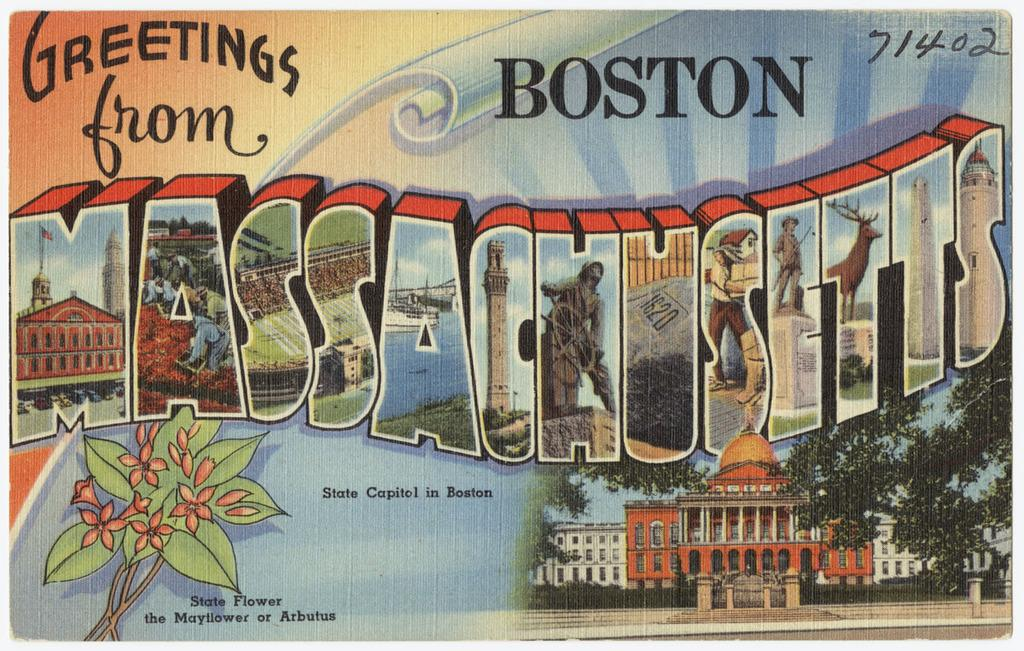<image>
Present a compact description of the photo's key features. Postcard that says "Greetings from Massachusetts" and the numbers 71402. 